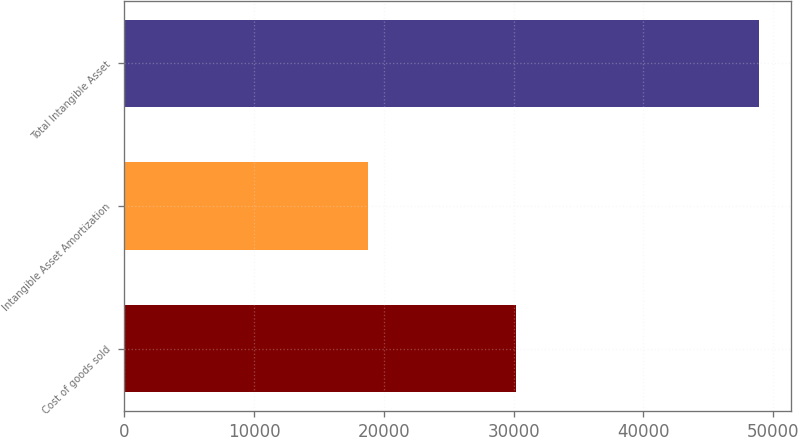<chart> <loc_0><loc_0><loc_500><loc_500><bar_chart><fcel>Cost of goods sold<fcel>Intangible Asset Amortization<fcel>Total Intangible Asset<nl><fcel>30164<fcel>18752<fcel>48916<nl></chart> 